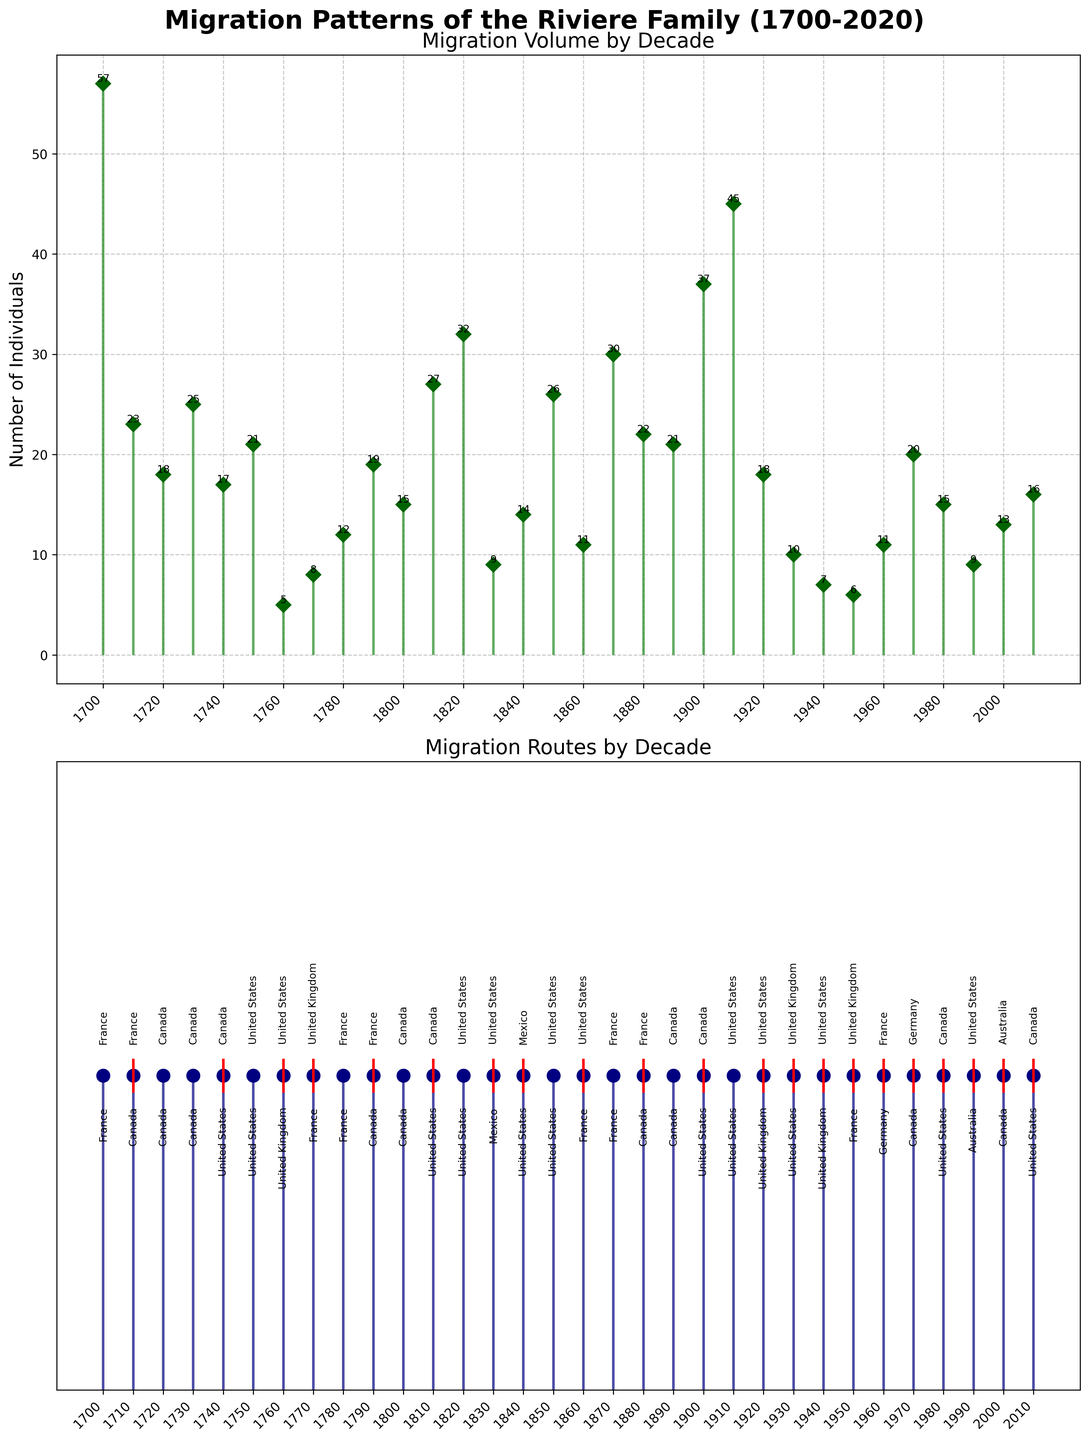What is the title of the figure? The title is written at the top of the figure as "Migration Patterns of the Riviere Family (1700-2020)"
Answer: Migration Patterns of the Riviere Family (1700-2020) How many individuals migrated from Canada to the United States in the 1900-1910 decade? In the first subplot of the stem plot, look for the data point corresponding to the 1900-1910 decade, which shows the number of individuals. The label “37” above the data point indicates the number of individuals who migrated from Canada to the United States.
Answer: 37 From which country did the Riviere family originally migrate in the 1710s? In the second subplot, the “origin” of the 1710s decade is labeled above the data point as “France.”
Answer: France How many total individuals migrated during the 1800s (1800-1890)? Sum the number of individuals in each decade of the 1800s: 15 (1800-1810) + 27 (1810-1820) + 32 (1820-1830) + 9 (1830-1840) + 14 (1840-1850) + 26 (1850-1860) + 11 (1860-1870) + 30 (1870-1880) + 22 (1880-1890) = 186
Answer: 186 Which decade saw the highest number of individuals migrating, and how many? In the first subplot, find the highest data point. The highest stem is for the 1910-1920 decade, and the label “45” indicates the number of individuals.
Answer: 1910-1920, 45 What is the average number of individuals migrating each decade in the 18th century (1700-1790)? Sum the number of individuals from each decade in the 18th century (1700-1790) and divide by the number of decades: (57 + 23 + 18 + 25 + 17 + 21 + 5 + 8 + 12 + 19) / 10 = 20.5
Answer: 20.5 In which decade did the Riviere family first migrate to Australia? Look for the decade and label in the second subplot where “Australia” is noted as the destination below the data point. This happens in 1990-2000.
Answer: 1990-2000 Between the 1940s and 1950s, did more individuals migrate to the United Kingdom or from the United Kingdom? In the second subplot, observe the data points for the 1940s and 1950s. From the labels, 7 people migrated to the United Kingdom (1940-1950), while 6 people migrated from the United Kingdom (1950-1960).
Answer: To the United Kingdom Determine the change in migration volume from 1950-1960 to 1960-1970. Find the data points in the first subplot and calculate the difference: 11 (1960-1970) - 6 (1950-1960) = 5.
Answer: 5 Which decade experienced the first migration from the United States to the United Kingdom? In the second subplot, observe the data points where “United States” is the origin and “United Kingdom” is the destination. This first occurs in the 1920-1930 decade.
Answer: 1920-1930 